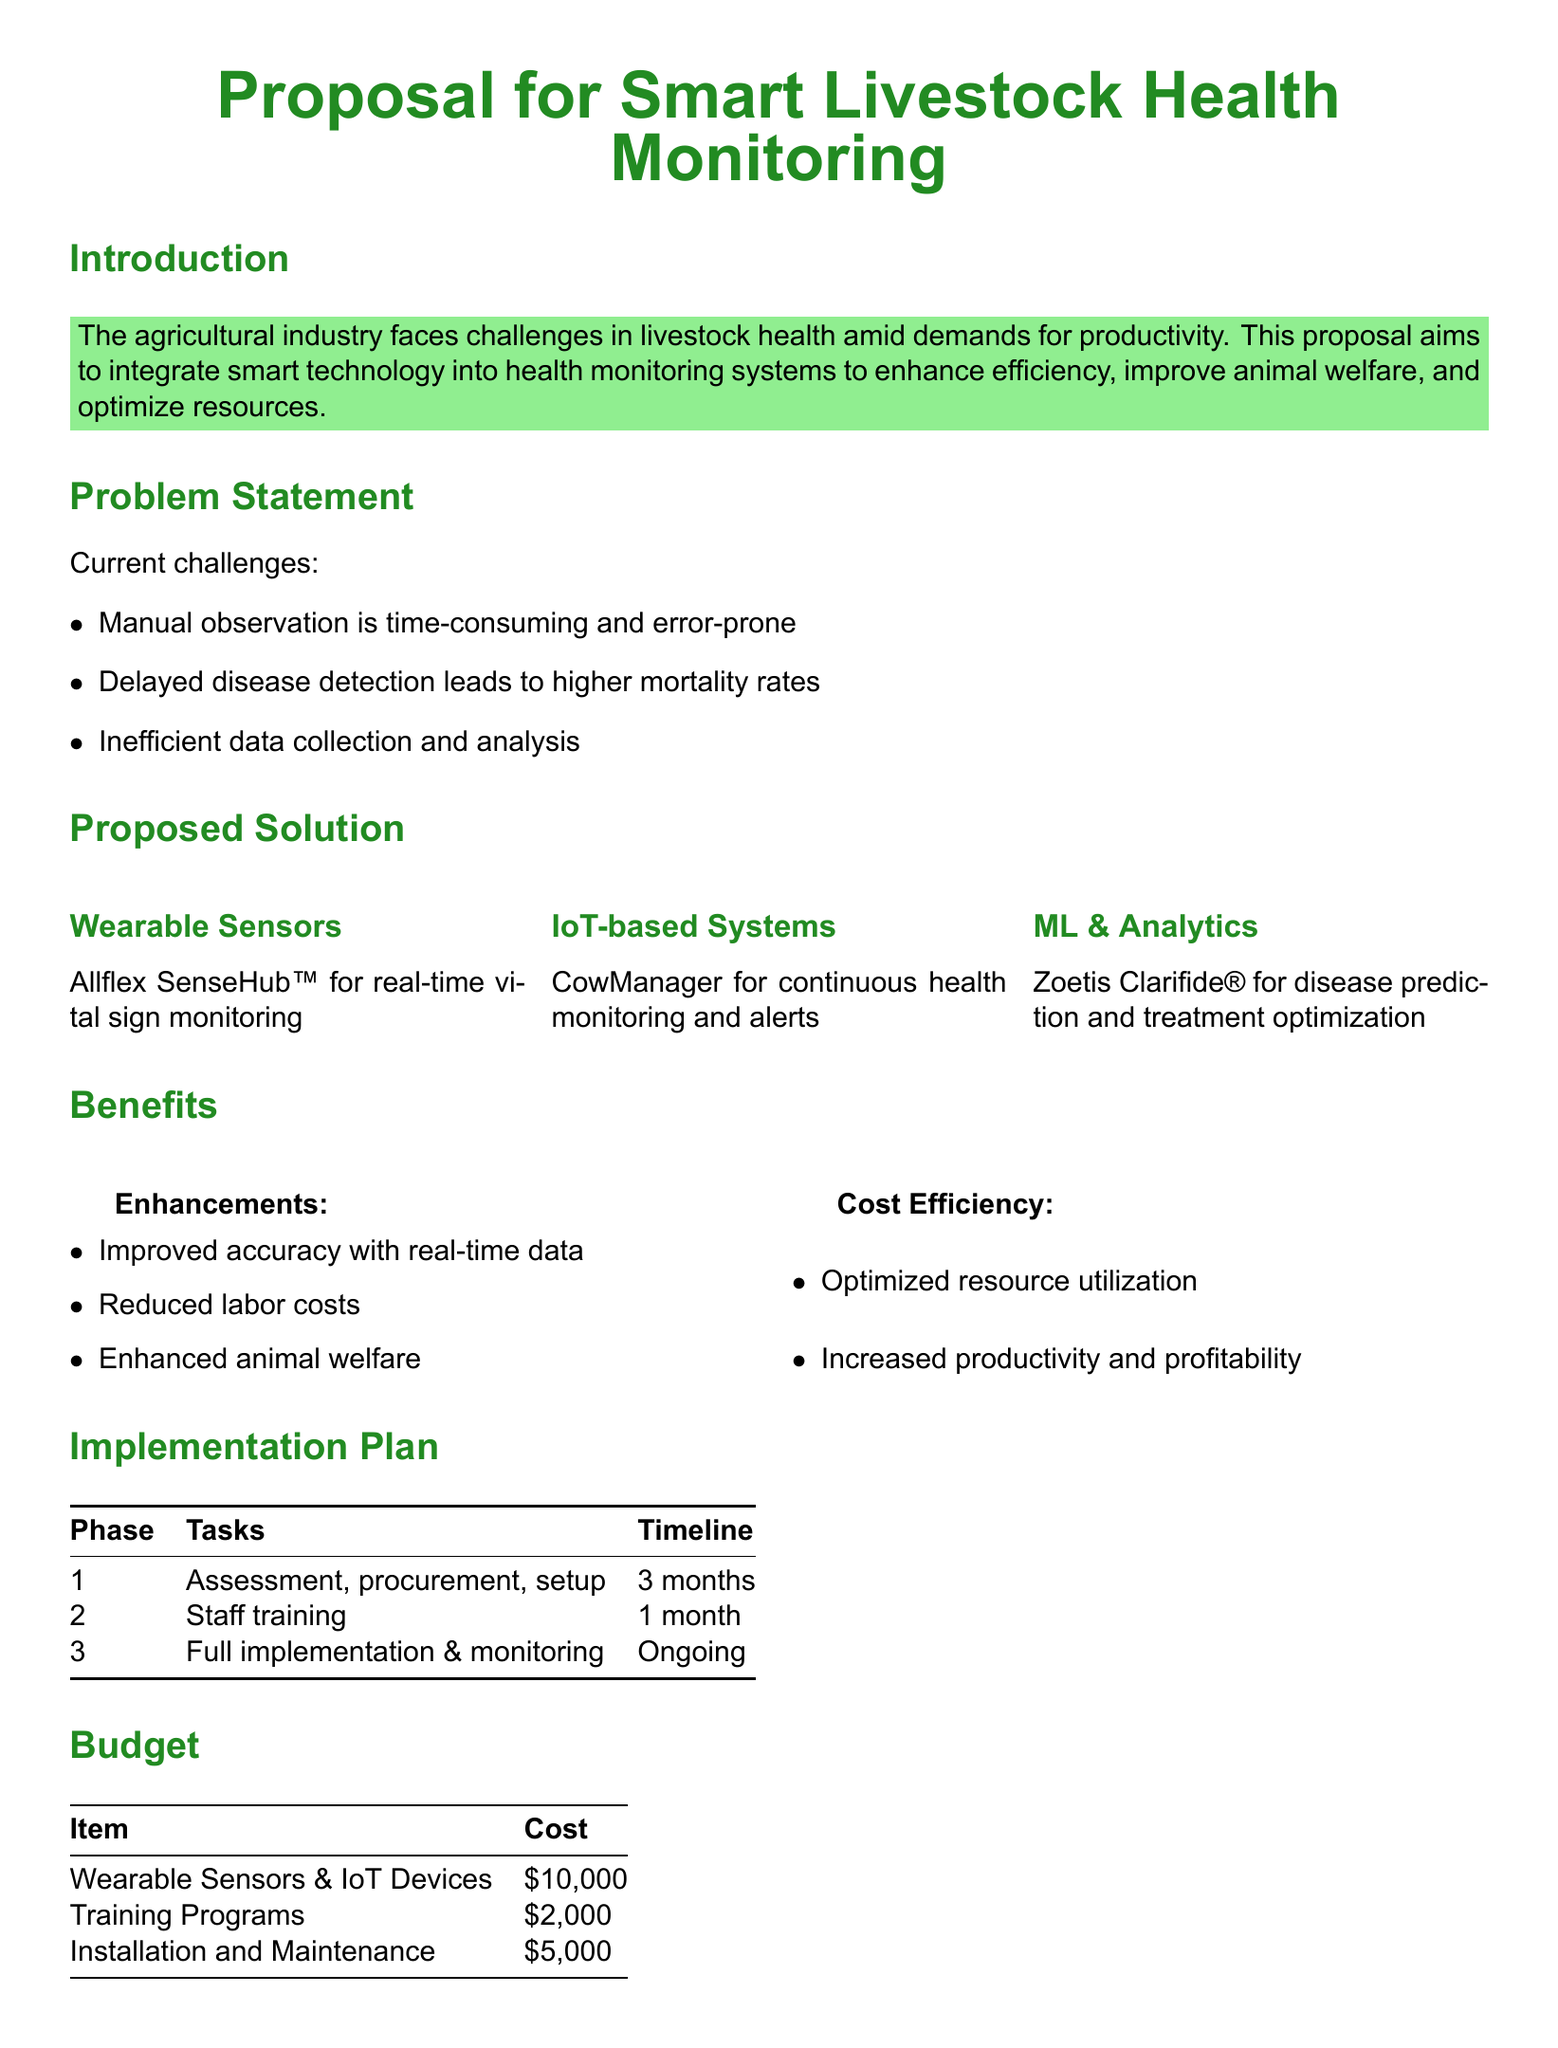What is the main goal of the proposal? The main goal is to enhance efficiency, improve animal welfare, and optimize resources through smart technology integration.
Answer: Enhance efficiency, improve animal welfare, and optimize resources What technology is suggested for real-time vital sign monitoring? The document specifies the Allflex SenseHub™ for real-time vital sign monitoring.
Answer: Allflex SenseHub™ How long is the assessment phase in the implementation plan? The assessment phase is outlined to take 3 months in the implementation plan.
Answer: 3 months What are the total costs for Wearable Sensors and IoT Devices? The total cost for Wearable Sensors and IoT Devices is listed as $10,000 in the budget section.
Answer: $10,000 What is a key benefit of using IoT-based systems? A key benefit of IoT-based systems mentioned is continuous health monitoring and alerts.
Answer: Continuous health monitoring and alerts What is the duration of the staff training phase? The staff training phase is stated to last for 1 month.
Answer: 1 month Which company offers disease prediction and treatment optimization? The Zoetis Clarifide® is mentioned as the company offering disease prediction and treatment optimization.
Answer: Zoetis Clarifide® What is the outcome mentioned in the conclusion of the proposal? The conclusion emphasizes significant improvement in animal welfare, productivity, and cost-efficiency.
Answer: Significant improvement in animal welfare, productivity, and cost-efficiency 